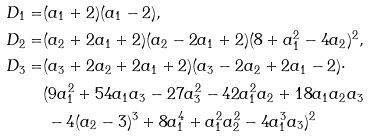<formula> <loc_0><loc_0><loc_500><loc_500>D _ { 1 } = & ( a _ { 1 } + 2 ) ( a _ { 1 } - 2 ) , \\ D _ { 2 } = & ( a _ { 2 } + 2 a _ { 1 } + 2 ) ( a _ { 2 } - 2 a _ { 1 } + 2 ) ( 8 + a _ { 1 } ^ { 2 } - 4 a _ { 2 } ) ^ { 2 } , \\ D _ { 3 } = & ( a _ { 3 } + 2 a _ { 2 } + 2 a _ { 1 } + 2 ) ( a _ { 3 } - 2 a _ { 2 } + 2 a _ { 1 } - 2 ) \cdot \\ & ( 9 a _ { 1 } ^ { 2 } + 5 4 a _ { 1 } a _ { 3 } - 2 7 a _ { 3 } ^ { 2 } - 4 2 a _ { 1 } ^ { 2 } a _ { 2 } + 1 8 a _ { 1 } a _ { 2 } a _ { 3 } \\ & \, - 4 ( a _ { 2 } - 3 ) ^ { 3 } + 8 a _ { 1 } ^ { 4 } + a _ { 1 } ^ { 2 } a _ { 2 } ^ { 2 } - 4 a _ { 1 } ^ { 3 } a _ { 3 } ) ^ { 2 }</formula> 